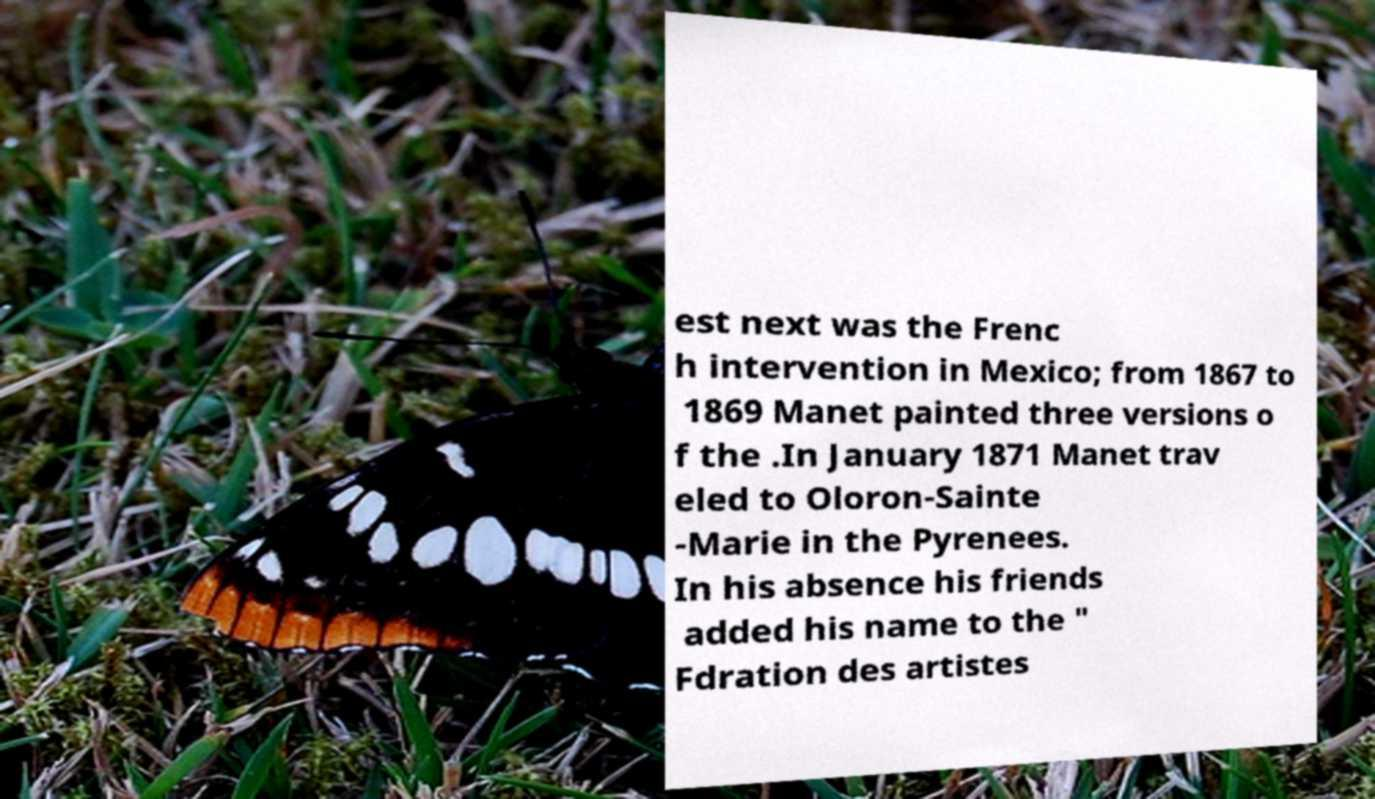I need the written content from this picture converted into text. Can you do that? est next was the Frenc h intervention in Mexico; from 1867 to 1869 Manet painted three versions o f the .In January 1871 Manet trav eled to Oloron-Sainte -Marie in the Pyrenees. In his absence his friends added his name to the " Fdration des artistes 